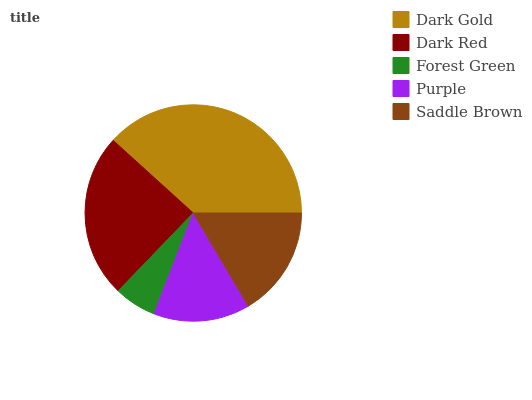Is Forest Green the minimum?
Answer yes or no. Yes. Is Dark Gold the maximum?
Answer yes or no. Yes. Is Dark Red the minimum?
Answer yes or no. No. Is Dark Red the maximum?
Answer yes or no. No. Is Dark Gold greater than Dark Red?
Answer yes or no. Yes. Is Dark Red less than Dark Gold?
Answer yes or no. Yes. Is Dark Red greater than Dark Gold?
Answer yes or no. No. Is Dark Gold less than Dark Red?
Answer yes or no. No. Is Saddle Brown the high median?
Answer yes or no. Yes. Is Saddle Brown the low median?
Answer yes or no. Yes. Is Forest Green the high median?
Answer yes or no. No. Is Purple the low median?
Answer yes or no. No. 